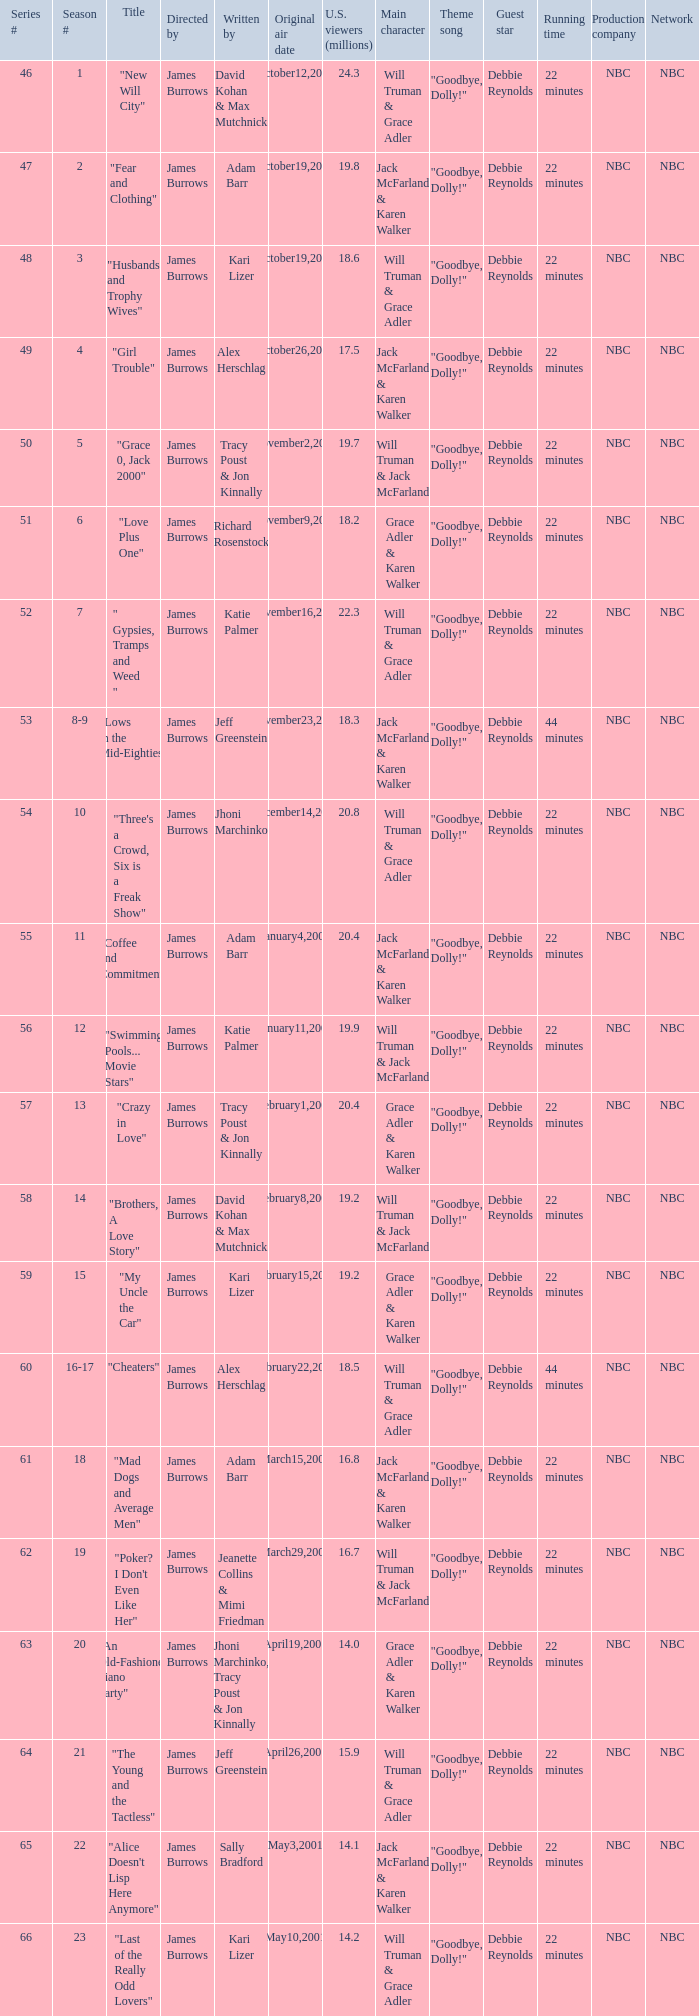Who wrote episode 23 in the season? Kari Lizer. 